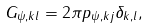Convert formula to latex. <formula><loc_0><loc_0><loc_500><loc_500>G _ { \psi , k l } = 2 \pi p _ { \psi , k j } \delta _ { k , l } ,</formula> 